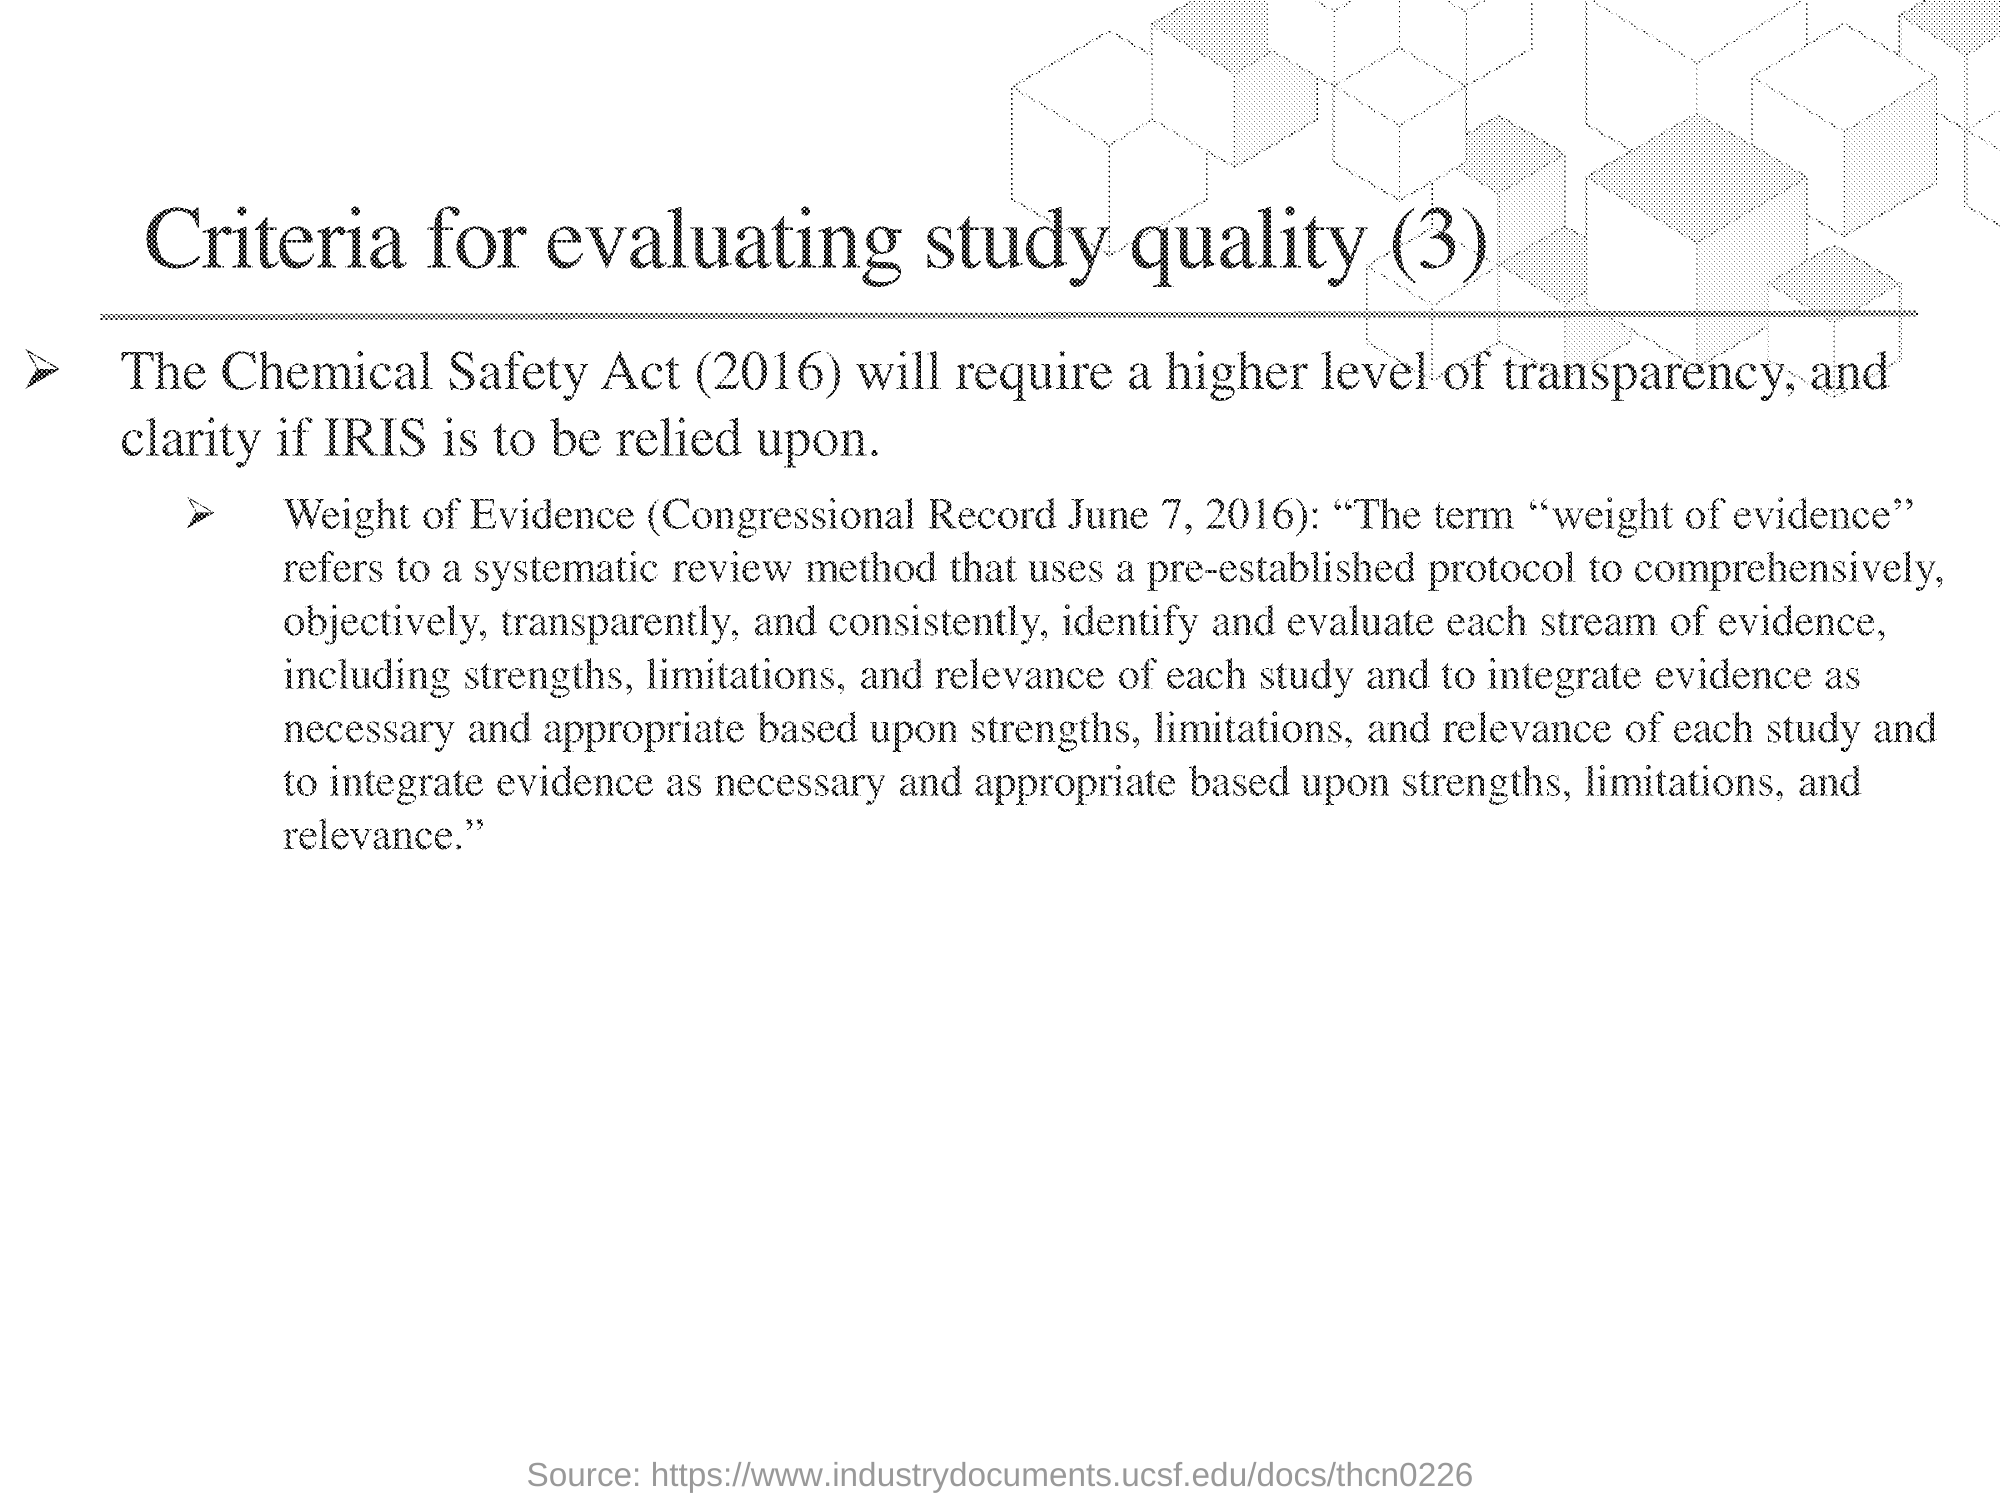Indicate a few pertinent items in this graphic. The title of this document is 'Criteria for Evaluating Study Quality (3)'. 